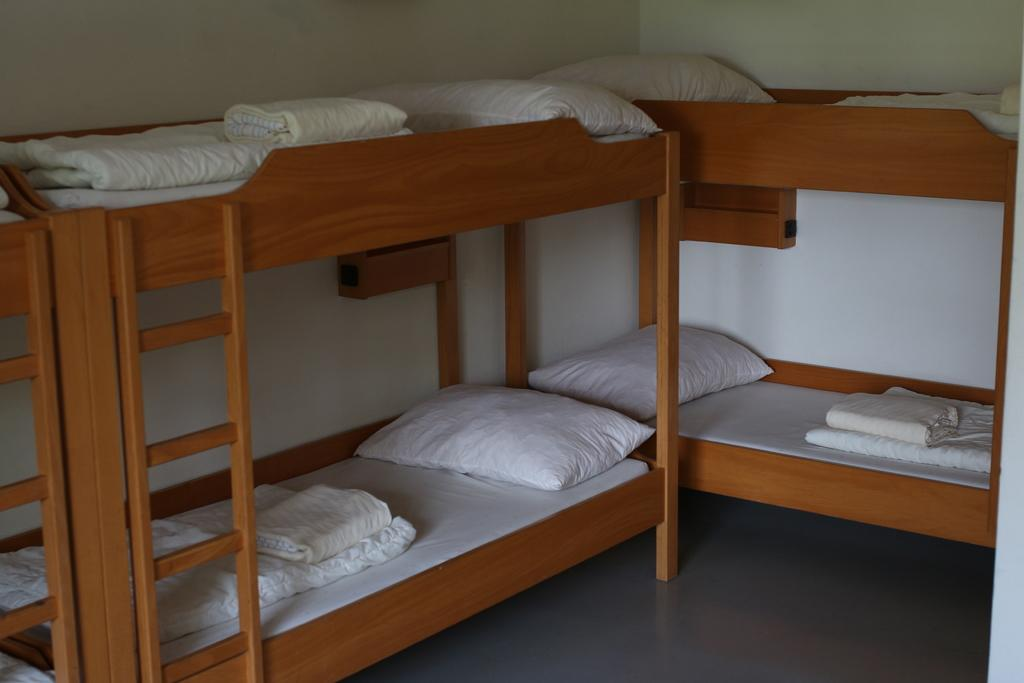What is placed on the beds in the image? There are pillows on the beds. What else can be seen on the beds? There are bed sheets on the beds. What type of joke is the farmer telling on the train in the image? There is no farmer, train, or joke present in the image. 